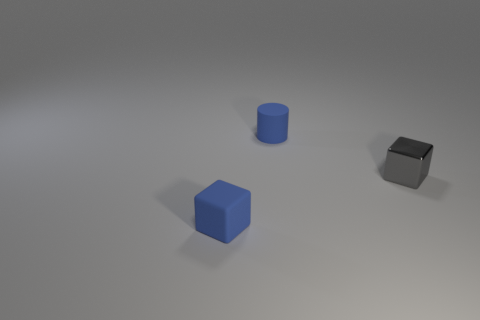Add 2 gray metallic objects. How many objects exist? 5 Subtract all blue blocks. How many blocks are left? 1 Subtract 1 blocks. How many blocks are left? 1 Subtract all cylinders. How many objects are left? 2 Subtract all red cubes. Subtract all gray cylinders. How many cubes are left? 2 Add 3 blue rubber cylinders. How many blue rubber cylinders are left? 4 Add 3 small red shiny blocks. How many small red shiny blocks exist? 3 Subtract 1 blue cylinders. How many objects are left? 2 Subtract all green matte things. Subtract all cylinders. How many objects are left? 2 